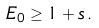Convert formula to latex. <formula><loc_0><loc_0><loc_500><loc_500>E _ { 0 } \geq 1 + s \, .</formula> 